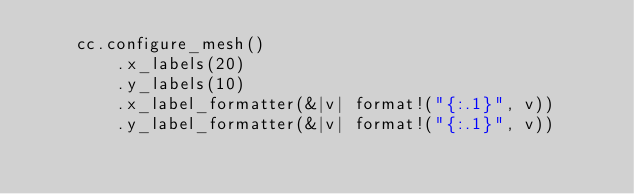<code> <loc_0><loc_0><loc_500><loc_500><_Rust_>    cc.configure_mesh()
        .x_labels(20)
        .y_labels(10)
        .x_label_formatter(&|v| format!("{:.1}", v))
        .y_label_formatter(&|v| format!("{:.1}", v))</code> 